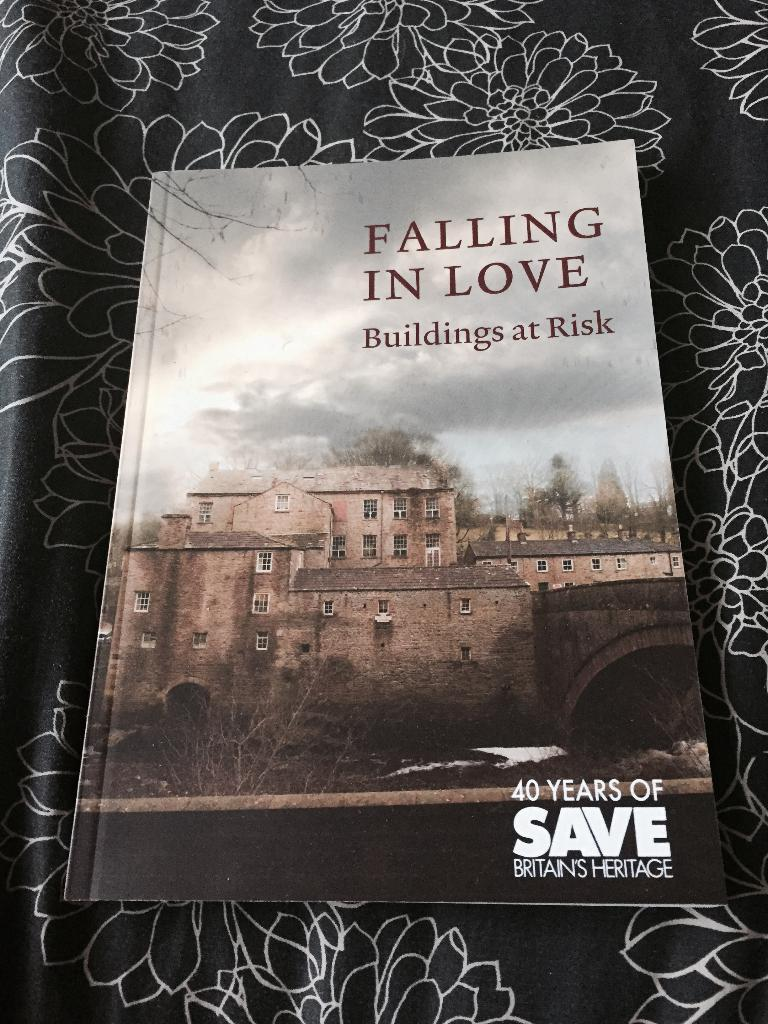<image>
Write a terse but informative summary of the picture. A book with a large building on it is titled Falling in Love. 